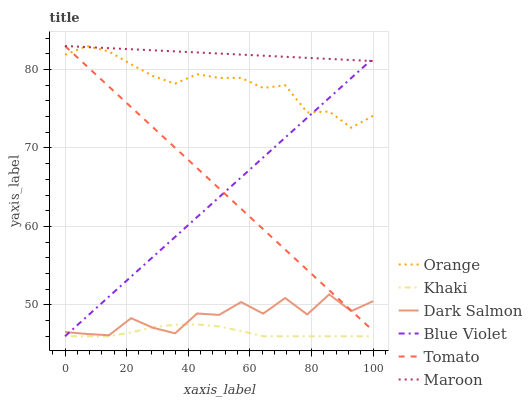Does Dark Salmon have the minimum area under the curve?
Answer yes or no. No. Does Dark Salmon have the maximum area under the curve?
Answer yes or no. No. Is Khaki the smoothest?
Answer yes or no. No. Is Khaki the roughest?
Answer yes or no. No. Does Dark Salmon have the lowest value?
Answer yes or no. No. Does Dark Salmon have the highest value?
Answer yes or no. No. Is Khaki less than Maroon?
Answer yes or no. Yes. Is Maroon greater than Khaki?
Answer yes or no. Yes. Does Khaki intersect Maroon?
Answer yes or no. No. 